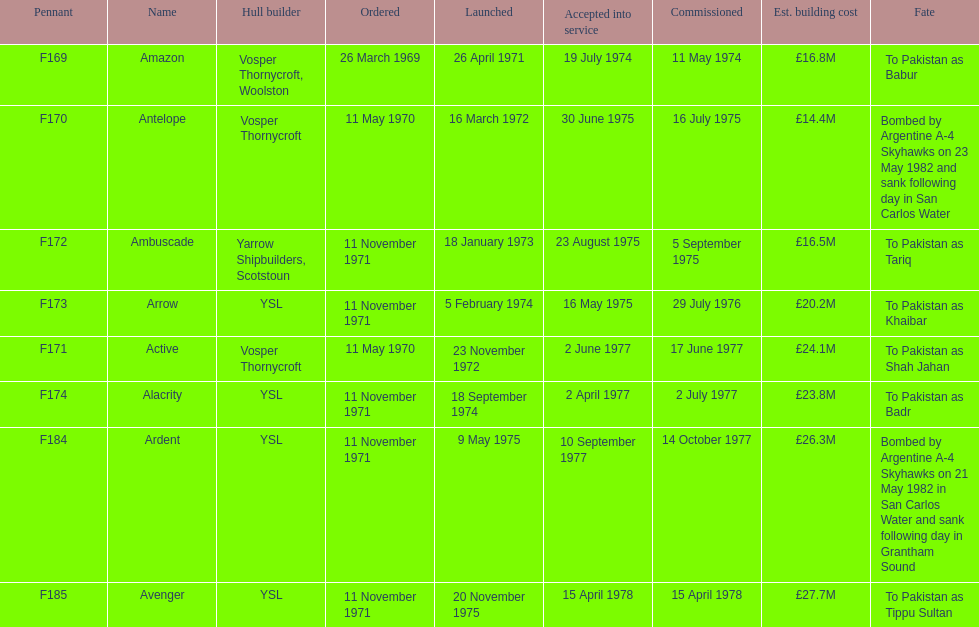Amazon is at the top of the chart, but what is the name below it? Antelope. 